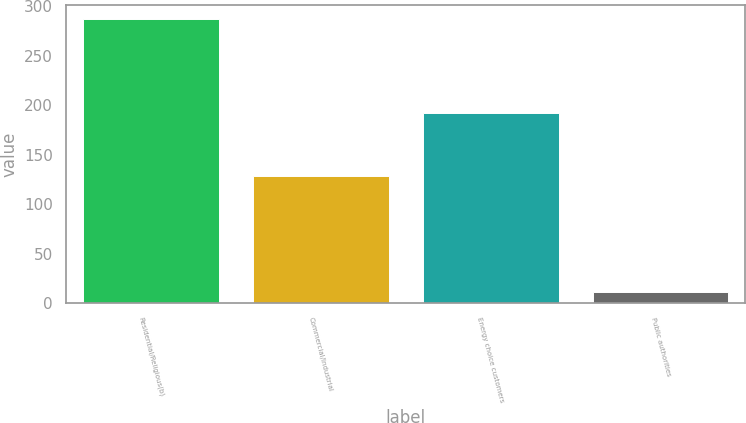<chart> <loc_0><loc_0><loc_500><loc_500><bar_chart><fcel>Residential/Religious(b)<fcel>Commercial/Industrial<fcel>Energy choice customers<fcel>Public authorities<nl><fcel>287<fcel>129<fcel>192<fcel>11<nl></chart> 